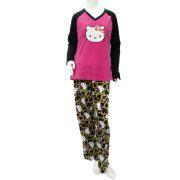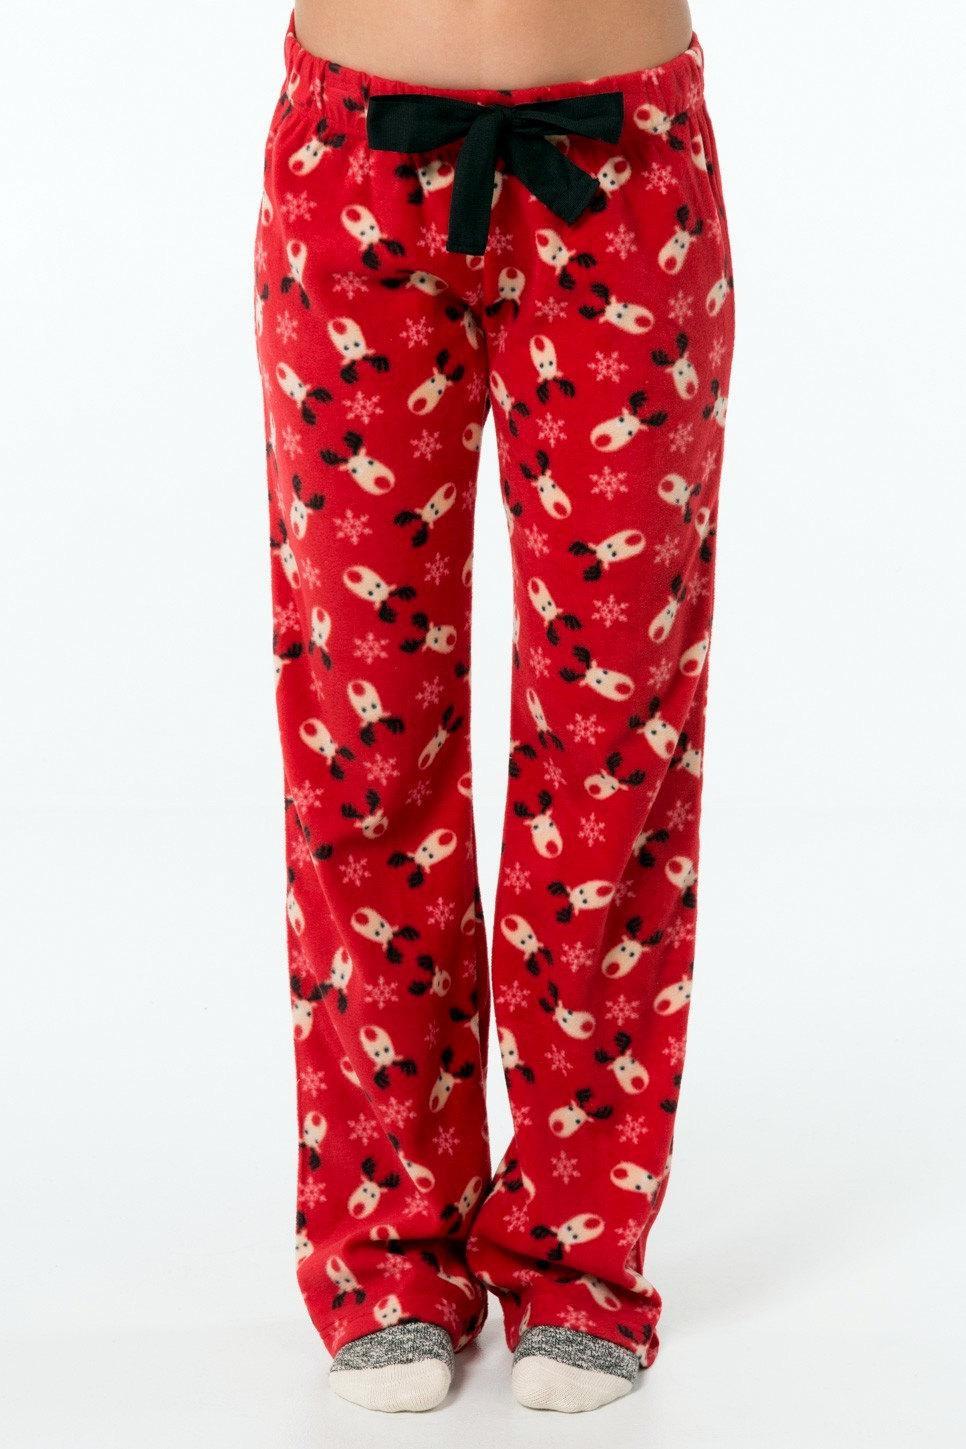The first image is the image on the left, the second image is the image on the right. Examine the images to the left and right. Is the description "One image features pajama pants with a square pattern." accurate? Answer yes or no. No. 